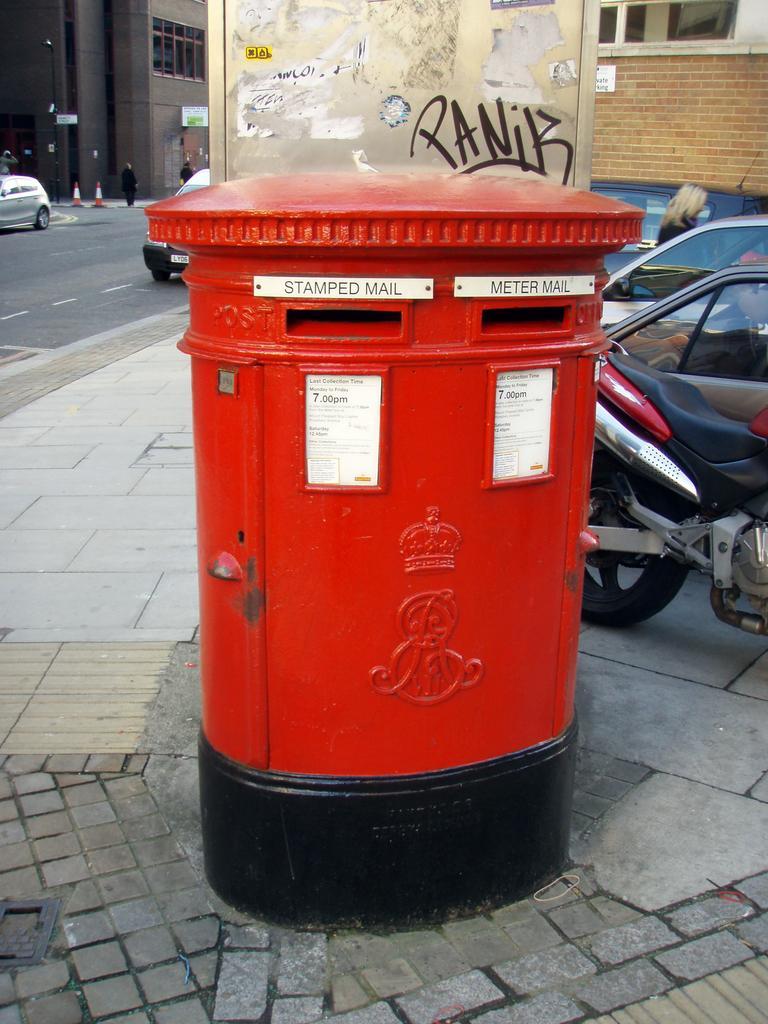How would you summarize this image in a sentence or two? In this picture I can see a post box, there are vehicles, there are four persons standing, there are cone bar barricades, buildings, boards. 